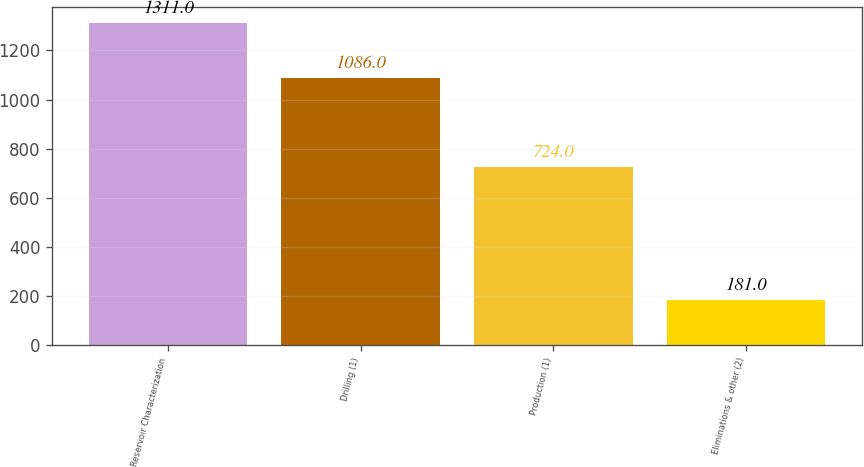Convert chart to OTSL. <chart><loc_0><loc_0><loc_500><loc_500><bar_chart><fcel>Reservoir Characterization<fcel>Drilling (1)<fcel>Production (1)<fcel>Eliminations & other (2)<nl><fcel>1311<fcel>1086<fcel>724<fcel>181<nl></chart> 